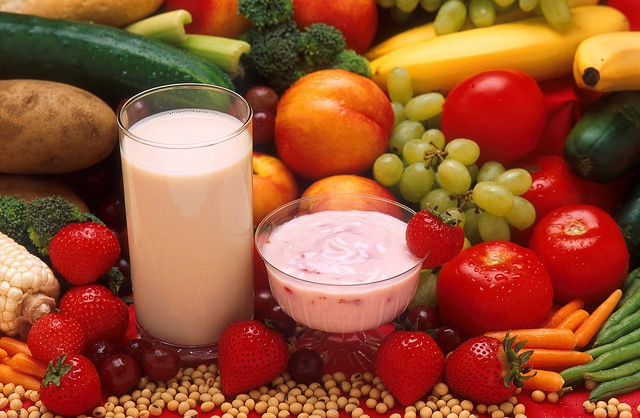Describe the objects in this image and their specific colors. I can see cup in tan, lightgray, and salmon tones, bowl in tan, pink, maroon, and salmon tones, banana in tan, orange, gold, red, and khaki tones, apple in tan, red, brown, and orange tones, and broccoli in tan, black, darkgreen, and maroon tones in this image. 